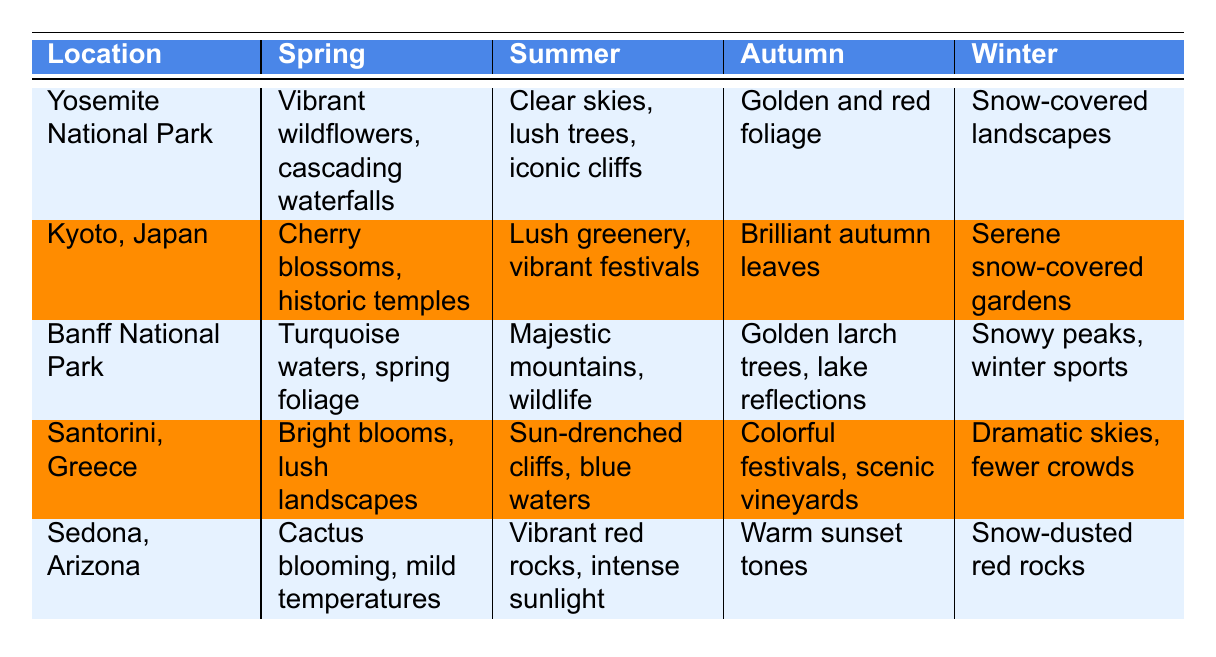What unique characteristics does Yosemite National Park exhibit in autumn? The table lists the unique characteristics for each season related to Yosemite National Park. For autumn, it states that the foliage transforms to golden and red hues, creating stunning contrast against granite rock formations.
Answer: Golden and red hues, stunning contrast against granite What season features cherry blossoms in Kyoto, Japan? The table specifically mentions that cherry blossoms are in full bloom during spring, enhancing the beauty of historic temples.
Answer: Spring Which location has vibrant red rocks under intense sunlight during summer? Referring to the summer characteristics in the table, Sedona, Arizona is described as having vibrant red rocks under intense sunlight, ideal for capturing dramatic contrasts.
Answer: Sedona, Arizona In which season do we see snow-covered landscapes at Banff National Park? Checking the winter characteristics in the table, it indicates that Banff National Park has snowy peaks and frozen lakes during winter.
Answer: Winter Which location is best for capturing iconic cliffs like El Capitan? The table states that in summer, Yosemite National Park is perfect for capturing iconic cliffs like El Capitan due to clear blue skies and lush green trees.
Answer: Yosemite National Park Is the autumn foliage in Banff National Park described as golden? According to the table, the unique characteristics for autumn in Banff National Park mention golden larch trees, so the statement is true.
Answer: Yes Identify the locations that have vibrant festivals in summer. The table shows that both Kyoto, Japan, and Santorini, Greece feature vibrant festivals during the summer season, making them the relevant locations.
Answer: Kyoto, Japan and Santorini, Greece Which location has snow-dusted red rocks in winter, and how many unique characteristics are listed for each season? Sedona, Arizona is the location with snow-dusted red rocks in winter. Additionally, each location has unique characteristics listed for all four seasons, making it a total of four unique characteristics per location.
Answer: Sedona, Arizona, four Summarize the differences between spring and autumn at Santorini, Greece. The spring characteristic is bright blooms and lush landscapes, while in autumn, it mentions colorful festivals and scenic vineyards. The key difference is the focus on blooms in spring versus festivals in autumn.
Answer: Different focuses on blooms vs. festivals Which location features serene snow-covered gardens in winter and vibrant wildflowers in spring? The table indicates that Kyoto, Japan has serene snow-covered gardens in winter, while Yosemite National Park features vibrant wildflowers blooming in spring.
Answer: Kyoto, Japan and Yosemite National Park 